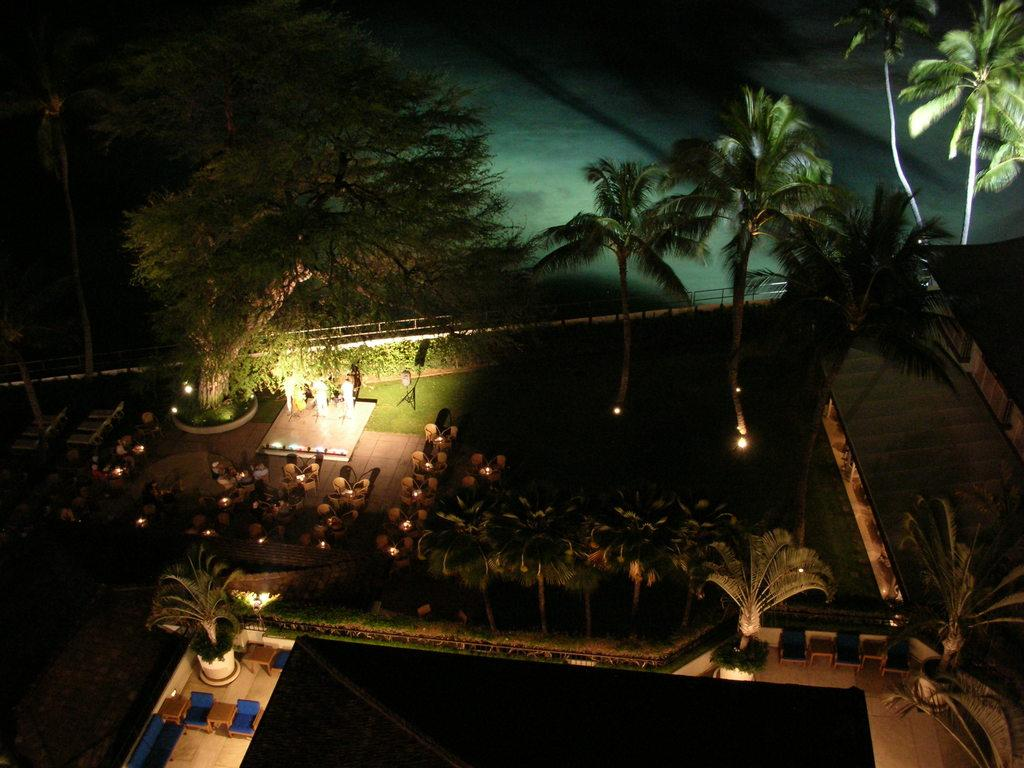What type of vegetation can be seen in the image? There are trees and plants in the image. What type of seating is present in the image? There are chairs in the image. What type of lighting is present in the image? There are lights in the image. What type of surface is visible at the bottom of the image? There is grass at the bottom of the image. What natural element is visible in the image? Water is visible in the image. What type of scarf is draped over the tree in the image? There is no scarf present in the image; it only features trees, plants, chairs, lights, water, and grass. What type of cheese is visible on the chairs in the image? There is no cheese present in the image; it only features chairs, lights, water, and grass. 